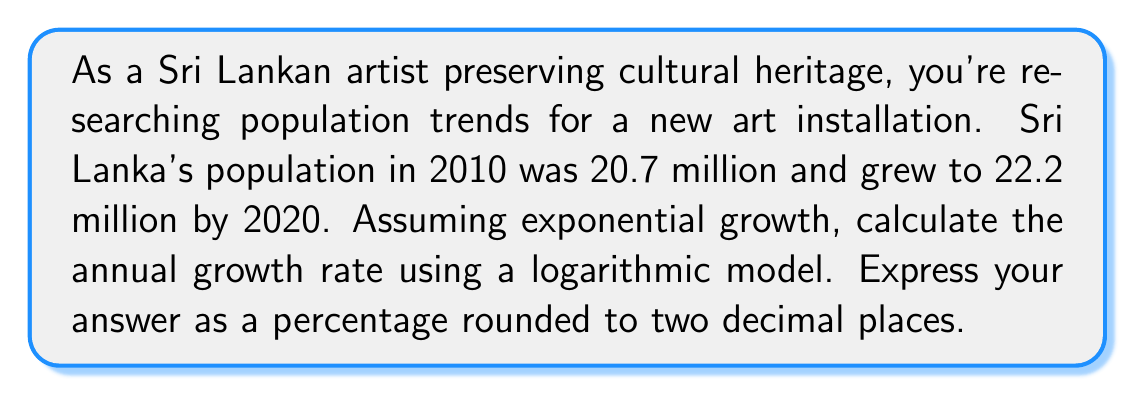Show me your answer to this math problem. Let's approach this step-by-step using the exponential growth formula and logarithms:

1) The exponential growth formula is:
   $$P(t) = P_0 \cdot e^{rt}$$
   where $P(t)$ is the population at time $t$, $P_0$ is the initial population, $r$ is the growth rate, and $t$ is the time period.

2) We know:
   $P_0 = 20.7$ million (2010 population)
   $P(t) = 22.2$ million (2020 population)
   $t = 10$ years

3) Substituting these values:
   $$22.2 = 20.7 \cdot e^{10r}$$

4) Divide both sides by 20.7:
   $$\frac{22.2}{20.7} = e^{10r}$$

5) Take the natural logarithm of both sides:
   $$\ln(\frac{22.2}{20.7}) = \ln(e^{10r})$$

6) Simplify the right side using logarithm properties:
   $$\ln(\frac{22.2}{20.7}) = 10r$$

7) Solve for $r$:
   $$r = \frac{\ln(\frac{22.2}{20.7})}{10}$$

8) Calculate:
   $$r = \frac{\ln(1.0724637681)}{10} \approx 0.00699$$

9) Convert to a percentage:
   $$0.00699 \times 100\% \approx 0.699\%$$

10) Round to two decimal places:
    $$0.70\%$$
Answer: 0.70% 